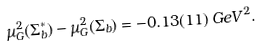<formula> <loc_0><loc_0><loc_500><loc_500>\mu _ { G } ^ { 2 } ( \Sigma _ { b } ^ { * } ) - \mu _ { G } ^ { 2 } ( \Sigma _ { b } ) = - 0 . 1 3 ( 1 1 ) \, G e V ^ { 2 } .</formula> 